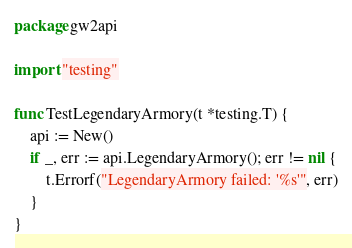Convert code to text. <code><loc_0><loc_0><loc_500><loc_500><_Go_>package gw2api

import "testing"

func TestLegendaryArmory(t *testing.T) {
	api := New()
	if _, err := api.LegendaryArmory(); err != nil {
		t.Errorf("LegendaryArmory failed: '%s'", err)
	}
}
</code> 